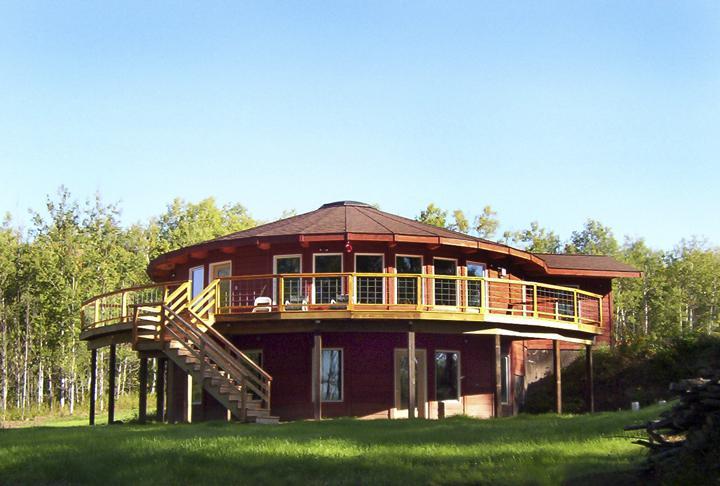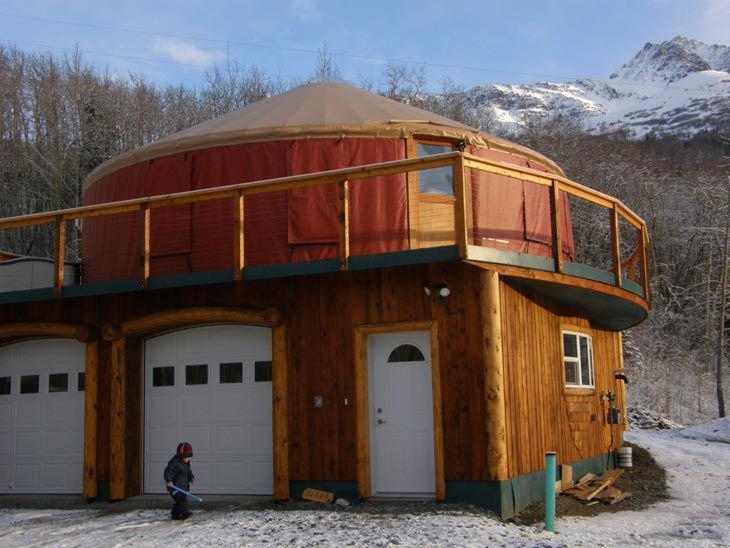The first image is the image on the left, the second image is the image on the right. For the images shown, is this caption "At least one image shows a model of a circular building, with a section removed to show the interior." true? Answer yes or no. No. The first image is the image on the left, the second image is the image on the right. Examine the images to the left and right. Is the description "The interior is shown of the hut in at least one of the images." accurate? Answer yes or no. No. 